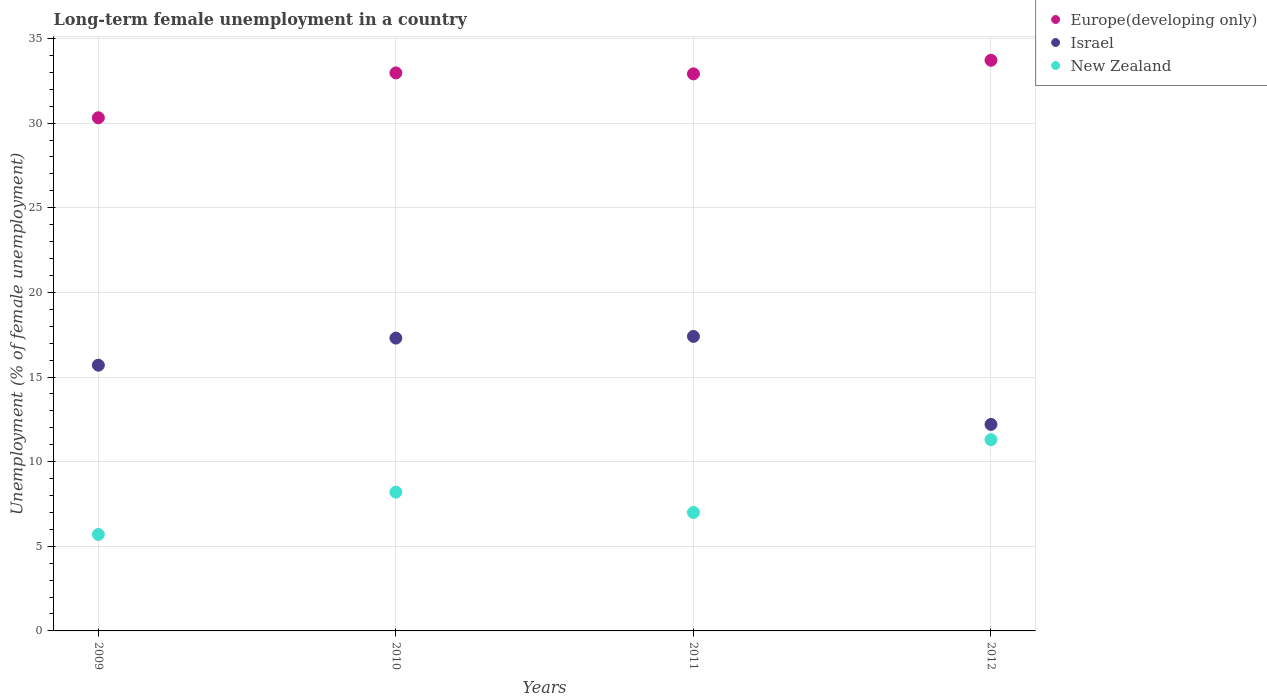How many different coloured dotlines are there?
Ensure brevity in your answer.  3. Is the number of dotlines equal to the number of legend labels?
Your answer should be compact. Yes. What is the percentage of long-term unemployed female population in New Zealand in 2010?
Give a very brief answer. 8.2. Across all years, what is the maximum percentage of long-term unemployed female population in Europe(developing only)?
Give a very brief answer. 33.71. Across all years, what is the minimum percentage of long-term unemployed female population in Europe(developing only)?
Offer a very short reply. 30.32. In which year was the percentage of long-term unemployed female population in Europe(developing only) maximum?
Provide a succinct answer. 2012. In which year was the percentage of long-term unemployed female population in Israel minimum?
Offer a very short reply. 2012. What is the total percentage of long-term unemployed female population in Israel in the graph?
Offer a terse response. 62.6. What is the difference between the percentage of long-term unemployed female population in Israel in 2009 and that in 2011?
Give a very brief answer. -1.7. What is the difference between the percentage of long-term unemployed female population in New Zealand in 2012 and the percentage of long-term unemployed female population in Israel in 2009?
Provide a short and direct response. -4.4. What is the average percentage of long-term unemployed female population in Europe(developing only) per year?
Provide a short and direct response. 32.48. In the year 2009, what is the difference between the percentage of long-term unemployed female population in Israel and percentage of long-term unemployed female population in Europe(developing only)?
Ensure brevity in your answer.  -14.62. What is the ratio of the percentage of long-term unemployed female population in New Zealand in 2010 to that in 2011?
Your answer should be very brief. 1.17. Is the percentage of long-term unemployed female population in New Zealand in 2010 less than that in 2011?
Your response must be concise. No. What is the difference between the highest and the second highest percentage of long-term unemployed female population in New Zealand?
Your response must be concise. 3.1. What is the difference between the highest and the lowest percentage of long-term unemployed female population in Europe(developing only)?
Your response must be concise. 3.4. In how many years, is the percentage of long-term unemployed female population in Europe(developing only) greater than the average percentage of long-term unemployed female population in Europe(developing only) taken over all years?
Provide a short and direct response. 3. Is the percentage of long-term unemployed female population in New Zealand strictly greater than the percentage of long-term unemployed female population in Israel over the years?
Give a very brief answer. No. Is the percentage of long-term unemployed female population in Israel strictly less than the percentage of long-term unemployed female population in New Zealand over the years?
Provide a short and direct response. No. How many dotlines are there?
Provide a short and direct response. 3. What is the difference between two consecutive major ticks on the Y-axis?
Your response must be concise. 5. Does the graph contain any zero values?
Keep it short and to the point. No. What is the title of the graph?
Make the answer very short. Long-term female unemployment in a country. Does "Slovenia" appear as one of the legend labels in the graph?
Keep it short and to the point. No. What is the label or title of the Y-axis?
Your answer should be compact. Unemployment (% of female unemployment). What is the Unemployment (% of female unemployment) in Europe(developing only) in 2009?
Ensure brevity in your answer.  30.32. What is the Unemployment (% of female unemployment) of Israel in 2009?
Provide a succinct answer. 15.7. What is the Unemployment (% of female unemployment) of New Zealand in 2009?
Keep it short and to the point. 5.7. What is the Unemployment (% of female unemployment) in Europe(developing only) in 2010?
Your answer should be very brief. 32.97. What is the Unemployment (% of female unemployment) in Israel in 2010?
Keep it short and to the point. 17.3. What is the Unemployment (% of female unemployment) in New Zealand in 2010?
Keep it short and to the point. 8.2. What is the Unemployment (% of female unemployment) in Europe(developing only) in 2011?
Your response must be concise. 32.91. What is the Unemployment (% of female unemployment) in Israel in 2011?
Your answer should be compact. 17.4. What is the Unemployment (% of female unemployment) in Europe(developing only) in 2012?
Your answer should be very brief. 33.71. What is the Unemployment (% of female unemployment) in Israel in 2012?
Your answer should be compact. 12.2. What is the Unemployment (% of female unemployment) of New Zealand in 2012?
Provide a succinct answer. 11.3. Across all years, what is the maximum Unemployment (% of female unemployment) of Europe(developing only)?
Give a very brief answer. 33.71. Across all years, what is the maximum Unemployment (% of female unemployment) of Israel?
Ensure brevity in your answer.  17.4. Across all years, what is the maximum Unemployment (% of female unemployment) in New Zealand?
Offer a terse response. 11.3. Across all years, what is the minimum Unemployment (% of female unemployment) in Europe(developing only)?
Your response must be concise. 30.32. Across all years, what is the minimum Unemployment (% of female unemployment) in Israel?
Make the answer very short. 12.2. Across all years, what is the minimum Unemployment (% of female unemployment) of New Zealand?
Ensure brevity in your answer.  5.7. What is the total Unemployment (% of female unemployment) of Europe(developing only) in the graph?
Your answer should be very brief. 129.91. What is the total Unemployment (% of female unemployment) of Israel in the graph?
Your response must be concise. 62.6. What is the total Unemployment (% of female unemployment) of New Zealand in the graph?
Give a very brief answer. 32.2. What is the difference between the Unemployment (% of female unemployment) of Europe(developing only) in 2009 and that in 2010?
Your answer should be very brief. -2.65. What is the difference between the Unemployment (% of female unemployment) in Europe(developing only) in 2009 and that in 2011?
Provide a succinct answer. -2.59. What is the difference between the Unemployment (% of female unemployment) in Israel in 2009 and that in 2011?
Provide a short and direct response. -1.7. What is the difference between the Unemployment (% of female unemployment) of Europe(developing only) in 2009 and that in 2012?
Provide a succinct answer. -3.4. What is the difference between the Unemployment (% of female unemployment) in Israel in 2009 and that in 2012?
Your answer should be compact. 3.5. What is the difference between the Unemployment (% of female unemployment) in New Zealand in 2009 and that in 2012?
Your answer should be compact. -5.6. What is the difference between the Unemployment (% of female unemployment) in Europe(developing only) in 2010 and that in 2011?
Ensure brevity in your answer.  0.06. What is the difference between the Unemployment (% of female unemployment) in Israel in 2010 and that in 2011?
Give a very brief answer. -0.1. What is the difference between the Unemployment (% of female unemployment) of Europe(developing only) in 2010 and that in 2012?
Offer a very short reply. -0.75. What is the difference between the Unemployment (% of female unemployment) in Europe(developing only) in 2011 and that in 2012?
Offer a terse response. -0.8. What is the difference between the Unemployment (% of female unemployment) in Israel in 2011 and that in 2012?
Make the answer very short. 5.2. What is the difference between the Unemployment (% of female unemployment) in New Zealand in 2011 and that in 2012?
Your response must be concise. -4.3. What is the difference between the Unemployment (% of female unemployment) in Europe(developing only) in 2009 and the Unemployment (% of female unemployment) in Israel in 2010?
Provide a succinct answer. 13.02. What is the difference between the Unemployment (% of female unemployment) in Europe(developing only) in 2009 and the Unemployment (% of female unemployment) in New Zealand in 2010?
Offer a terse response. 22.12. What is the difference between the Unemployment (% of female unemployment) of Israel in 2009 and the Unemployment (% of female unemployment) of New Zealand in 2010?
Ensure brevity in your answer.  7.5. What is the difference between the Unemployment (% of female unemployment) in Europe(developing only) in 2009 and the Unemployment (% of female unemployment) in Israel in 2011?
Your answer should be compact. 12.92. What is the difference between the Unemployment (% of female unemployment) of Europe(developing only) in 2009 and the Unemployment (% of female unemployment) of New Zealand in 2011?
Your answer should be very brief. 23.32. What is the difference between the Unemployment (% of female unemployment) in Europe(developing only) in 2009 and the Unemployment (% of female unemployment) in Israel in 2012?
Make the answer very short. 18.12. What is the difference between the Unemployment (% of female unemployment) of Europe(developing only) in 2009 and the Unemployment (% of female unemployment) of New Zealand in 2012?
Your answer should be very brief. 19.02. What is the difference between the Unemployment (% of female unemployment) in Israel in 2009 and the Unemployment (% of female unemployment) in New Zealand in 2012?
Your answer should be very brief. 4.4. What is the difference between the Unemployment (% of female unemployment) of Europe(developing only) in 2010 and the Unemployment (% of female unemployment) of Israel in 2011?
Keep it short and to the point. 15.57. What is the difference between the Unemployment (% of female unemployment) in Europe(developing only) in 2010 and the Unemployment (% of female unemployment) in New Zealand in 2011?
Provide a short and direct response. 25.97. What is the difference between the Unemployment (% of female unemployment) of Europe(developing only) in 2010 and the Unemployment (% of female unemployment) of Israel in 2012?
Give a very brief answer. 20.77. What is the difference between the Unemployment (% of female unemployment) of Europe(developing only) in 2010 and the Unemployment (% of female unemployment) of New Zealand in 2012?
Keep it short and to the point. 21.67. What is the difference between the Unemployment (% of female unemployment) in Israel in 2010 and the Unemployment (% of female unemployment) in New Zealand in 2012?
Make the answer very short. 6. What is the difference between the Unemployment (% of female unemployment) of Europe(developing only) in 2011 and the Unemployment (% of female unemployment) of Israel in 2012?
Keep it short and to the point. 20.71. What is the difference between the Unemployment (% of female unemployment) in Europe(developing only) in 2011 and the Unemployment (% of female unemployment) in New Zealand in 2012?
Offer a terse response. 21.61. What is the difference between the Unemployment (% of female unemployment) of Israel in 2011 and the Unemployment (% of female unemployment) of New Zealand in 2012?
Your answer should be very brief. 6.1. What is the average Unemployment (% of female unemployment) of Europe(developing only) per year?
Your response must be concise. 32.48. What is the average Unemployment (% of female unemployment) of Israel per year?
Make the answer very short. 15.65. What is the average Unemployment (% of female unemployment) in New Zealand per year?
Ensure brevity in your answer.  8.05. In the year 2009, what is the difference between the Unemployment (% of female unemployment) of Europe(developing only) and Unemployment (% of female unemployment) of Israel?
Make the answer very short. 14.62. In the year 2009, what is the difference between the Unemployment (% of female unemployment) of Europe(developing only) and Unemployment (% of female unemployment) of New Zealand?
Offer a very short reply. 24.62. In the year 2009, what is the difference between the Unemployment (% of female unemployment) in Israel and Unemployment (% of female unemployment) in New Zealand?
Provide a succinct answer. 10. In the year 2010, what is the difference between the Unemployment (% of female unemployment) in Europe(developing only) and Unemployment (% of female unemployment) in Israel?
Keep it short and to the point. 15.67. In the year 2010, what is the difference between the Unemployment (% of female unemployment) of Europe(developing only) and Unemployment (% of female unemployment) of New Zealand?
Offer a terse response. 24.77. In the year 2011, what is the difference between the Unemployment (% of female unemployment) of Europe(developing only) and Unemployment (% of female unemployment) of Israel?
Your answer should be very brief. 15.51. In the year 2011, what is the difference between the Unemployment (% of female unemployment) in Europe(developing only) and Unemployment (% of female unemployment) in New Zealand?
Your response must be concise. 25.91. In the year 2011, what is the difference between the Unemployment (% of female unemployment) of Israel and Unemployment (% of female unemployment) of New Zealand?
Your response must be concise. 10.4. In the year 2012, what is the difference between the Unemployment (% of female unemployment) of Europe(developing only) and Unemployment (% of female unemployment) of Israel?
Your answer should be compact. 21.51. In the year 2012, what is the difference between the Unemployment (% of female unemployment) of Europe(developing only) and Unemployment (% of female unemployment) of New Zealand?
Your response must be concise. 22.41. In the year 2012, what is the difference between the Unemployment (% of female unemployment) in Israel and Unemployment (% of female unemployment) in New Zealand?
Provide a succinct answer. 0.9. What is the ratio of the Unemployment (% of female unemployment) in Europe(developing only) in 2009 to that in 2010?
Ensure brevity in your answer.  0.92. What is the ratio of the Unemployment (% of female unemployment) in Israel in 2009 to that in 2010?
Keep it short and to the point. 0.91. What is the ratio of the Unemployment (% of female unemployment) of New Zealand in 2009 to that in 2010?
Ensure brevity in your answer.  0.7. What is the ratio of the Unemployment (% of female unemployment) of Europe(developing only) in 2009 to that in 2011?
Provide a short and direct response. 0.92. What is the ratio of the Unemployment (% of female unemployment) of Israel in 2009 to that in 2011?
Give a very brief answer. 0.9. What is the ratio of the Unemployment (% of female unemployment) of New Zealand in 2009 to that in 2011?
Keep it short and to the point. 0.81. What is the ratio of the Unemployment (% of female unemployment) of Europe(developing only) in 2009 to that in 2012?
Make the answer very short. 0.9. What is the ratio of the Unemployment (% of female unemployment) in Israel in 2009 to that in 2012?
Offer a very short reply. 1.29. What is the ratio of the Unemployment (% of female unemployment) of New Zealand in 2009 to that in 2012?
Keep it short and to the point. 0.5. What is the ratio of the Unemployment (% of female unemployment) of Israel in 2010 to that in 2011?
Offer a terse response. 0.99. What is the ratio of the Unemployment (% of female unemployment) in New Zealand in 2010 to that in 2011?
Ensure brevity in your answer.  1.17. What is the ratio of the Unemployment (% of female unemployment) in Europe(developing only) in 2010 to that in 2012?
Ensure brevity in your answer.  0.98. What is the ratio of the Unemployment (% of female unemployment) in Israel in 2010 to that in 2012?
Ensure brevity in your answer.  1.42. What is the ratio of the Unemployment (% of female unemployment) of New Zealand in 2010 to that in 2012?
Ensure brevity in your answer.  0.73. What is the ratio of the Unemployment (% of female unemployment) of Europe(developing only) in 2011 to that in 2012?
Your response must be concise. 0.98. What is the ratio of the Unemployment (% of female unemployment) in Israel in 2011 to that in 2012?
Make the answer very short. 1.43. What is the ratio of the Unemployment (% of female unemployment) of New Zealand in 2011 to that in 2012?
Provide a succinct answer. 0.62. What is the difference between the highest and the second highest Unemployment (% of female unemployment) of Europe(developing only)?
Provide a short and direct response. 0.75. What is the difference between the highest and the lowest Unemployment (% of female unemployment) in Europe(developing only)?
Make the answer very short. 3.4. What is the difference between the highest and the lowest Unemployment (% of female unemployment) in New Zealand?
Ensure brevity in your answer.  5.6. 